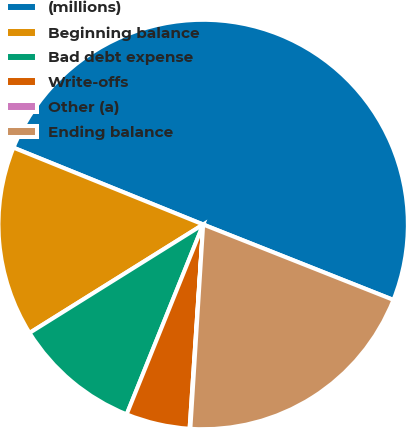Convert chart to OTSL. <chart><loc_0><loc_0><loc_500><loc_500><pie_chart><fcel>(millions)<fcel>Beginning balance<fcel>Bad debt expense<fcel>Write-offs<fcel>Other (a)<fcel>Ending balance<nl><fcel>49.88%<fcel>15.01%<fcel>10.02%<fcel>5.04%<fcel>0.06%<fcel>19.99%<nl></chart> 